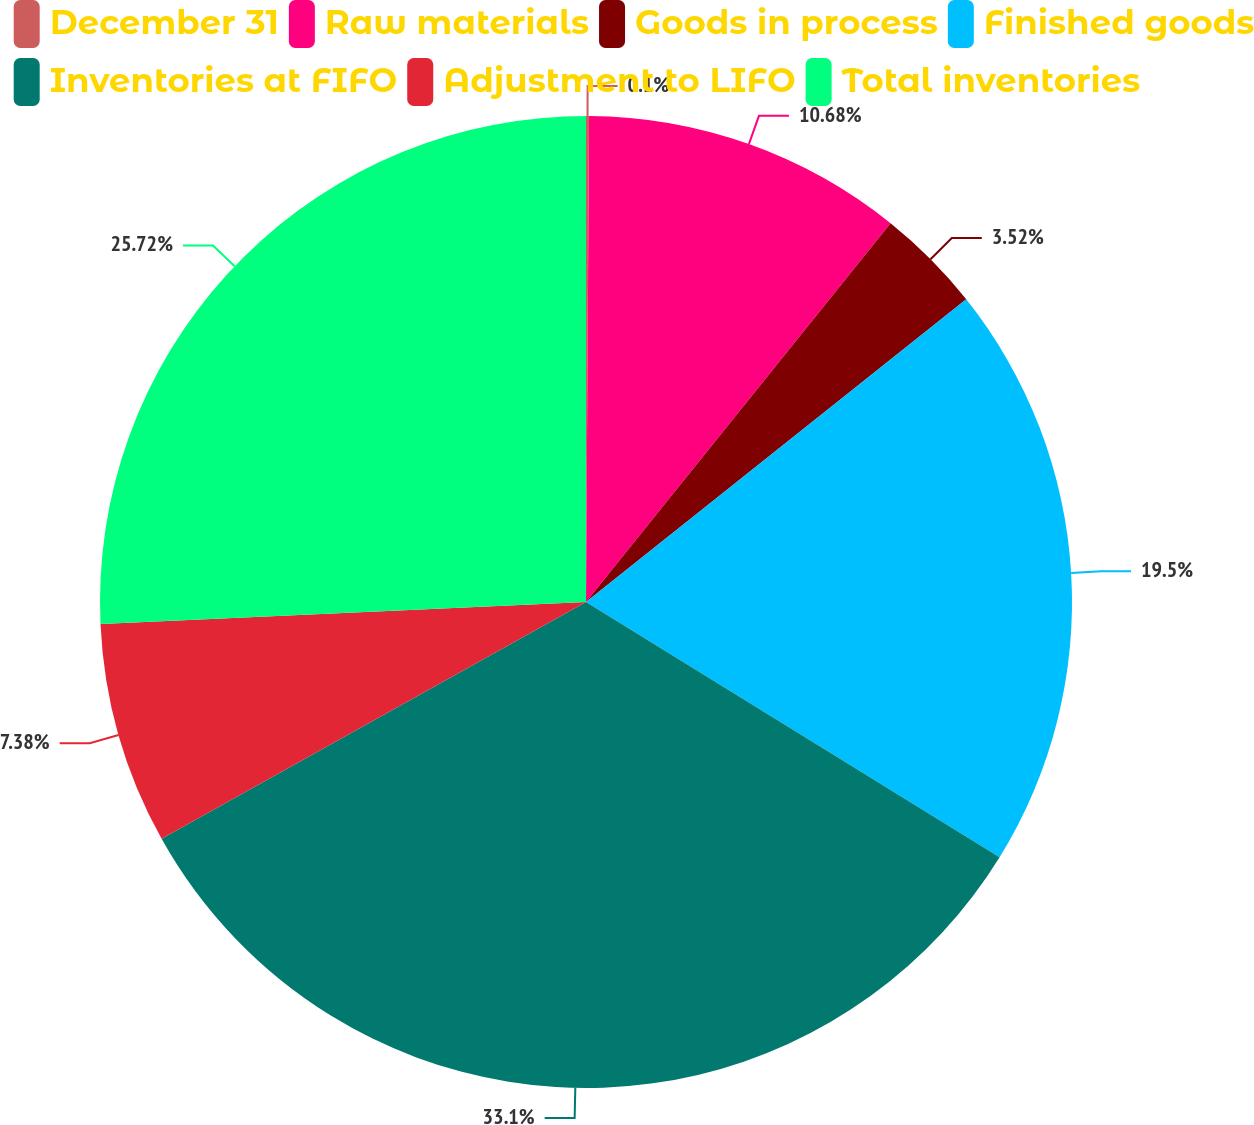Convert chart. <chart><loc_0><loc_0><loc_500><loc_500><pie_chart><fcel>December 31<fcel>Raw materials<fcel>Goods in process<fcel>Finished goods<fcel>Inventories at FIFO<fcel>Adjustment to LIFO<fcel>Total inventories<nl><fcel>0.1%<fcel>10.68%<fcel>3.52%<fcel>19.5%<fcel>33.1%<fcel>7.38%<fcel>25.72%<nl></chart> 